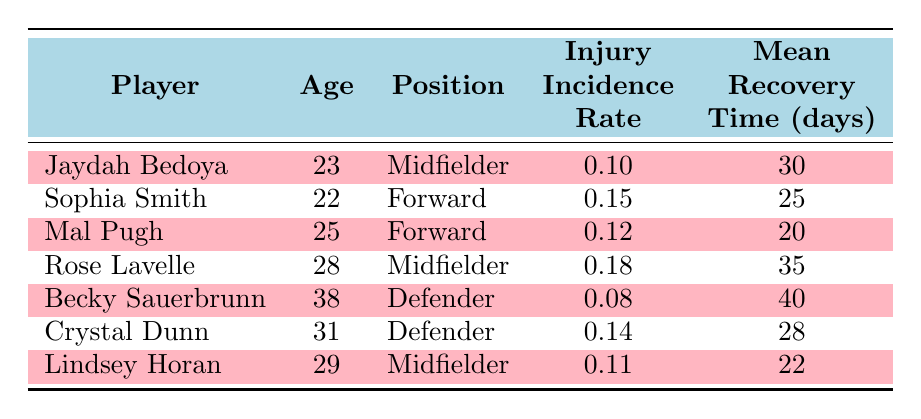What is the injury incidence rate for Jaydah Bedoya? The table shows the injury incidence rate listed under Jaydah Bedoya's entry, which is 0.10.
Answer: 0.10 What position does Sophia Smith play? According to the table, Sophia Smith is listed under the "Position" column as a Forward.
Answer: Forward Who has the highest mean recovery time? By examining the "Mean Recovery Time (days)" column, Rose Lavelle has the highest value at 35 days.
Answer: Rose Lavelle What is the average injury incidence rate for all players? To find the average, we add the injury incidence rates: (0.10 + 0.15 + 0.12 + 0.18 + 0.08 + 0.14 + 0.11) = 0.88. There are 7 players, so the average is 0.88 / 7 = 0.1257, which rounds to approximately 0.13.
Answer: 0.13 Is Crystal Dunn older than Mal Pugh? Looking at the "Age" column, Crystal Dunn is 31 years old while Mal Pugh is 25 years old, confirming that Crystal Dunn is indeed older.
Answer: Yes What is the sum of mean recovery times for defenders? From the table, the mean recovery times for defenders (Becky Sauerbrunn at 40 days and Crystal Dunn at 28 days) are summed up: 40 + 28 = 68 days.
Answer: 68 days Which player has the lowest injury incidence rate? By comparing the "Injury Incidence Rate" column, Becky Sauerbrunn has the lowest rate at 0.08.
Answer: Becky Sauerbrunn What age-related trend can be observed regarding injury incidence rates? Analyzing the "Age" and "Injury Incidence Rate" columns, it appears that as age increases (from Jaydah Bedoya to Becky Sauerbrunn), the incidence rates vary without a strict upward or downward trend; however, the oldest player, Becky Sauerbrunn, has the lowest injury incidence rate.
Answer: No strict trend Which player has a recovery time lower than 30 days? Reviewing the "Mean Recovery Time (days)" column, both Mal Pugh (20 days) and Lindsey Horan (22 days) have recovery times that are less than 30 days.
Answer: Mal Pugh and Lindsey Horan 